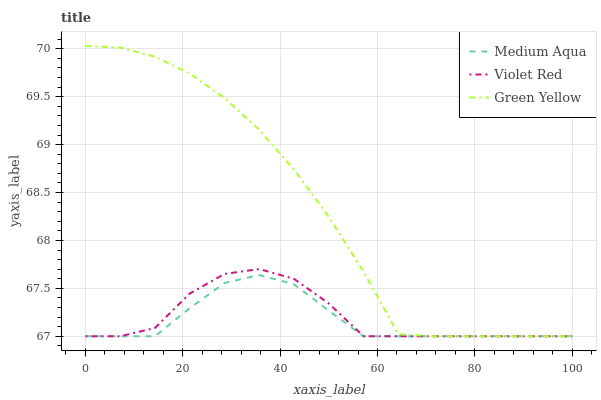Does Medium Aqua have the minimum area under the curve?
Answer yes or no. Yes. Does Green Yellow have the maximum area under the curve?
Answer yes or no. Yes. Does Green Yellow have the minimum area under the curve?
Answer yes or no. No. Does Medium Aqua have the maximum area under the curve?
Answer yes or no. No. Is Medium Aqua the smoothest?
Answer yes or no. Yes. Is Violet Red the roughest?
Answer yes or no. Yes. Is Green Yellow the smoothest?
Answer yes or no. No. Is Green Yellow the roughest?
Answer yes or no. No. Does Violet Red have the lowest value?
Answer yes or no. Yes. Does Green Yellow have the highest value?
Answer yes or no. Yes. Does Medium Aqua have the highest value?
Answer yes or no. No. Does Green Yellow intersect Violet Red?
Answer yes or no. Yes. Is Green Yellow less than Violet Red?
Answer yes or no. No. Is Green Yellow greater than Violet Red?
Answer yes or no. No. 